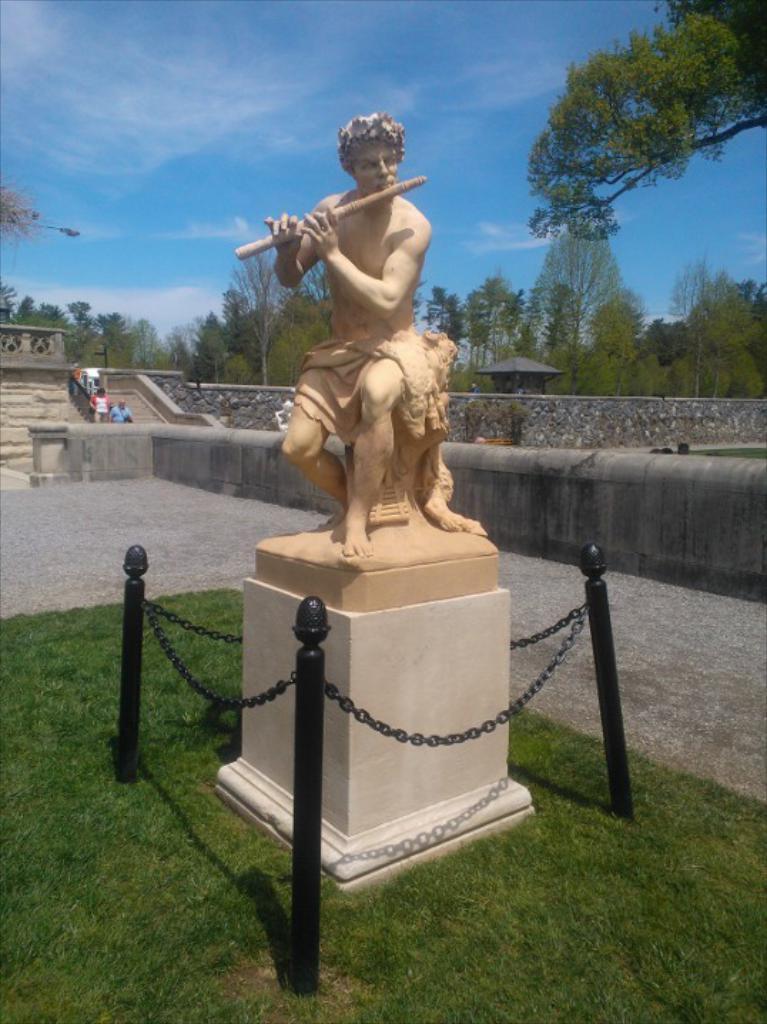Describe this image in one or two sentences. In this image we can see the statue of a man, and on the ground we can see the grass, and at the back we can see some people walking, and background is the sky. 